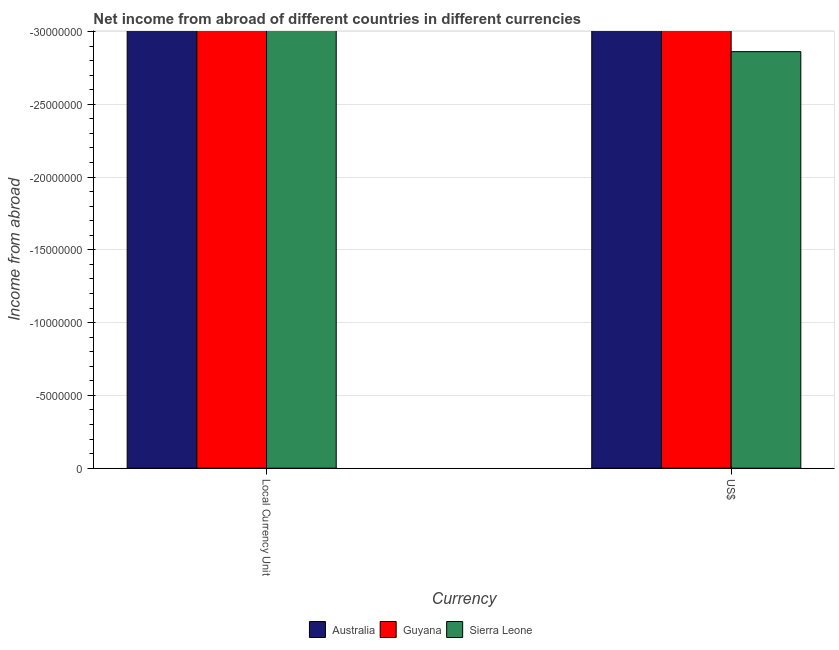How many different coloured bars are there?
Ensure brevity in your answer.  0. How many bars are there on the 2nd tick from the right?
Give a very brief answer. 0. What is the label of the 2nd group of bars from the left?
Ensure brevity in your answer.  US$. Across all countries, what is the minimum income from abroad in constant 2005 us$?
Your answer should be very brief. 0. What is the total income from abroad in constant 2005 us$ in the graph?
Provide a succinct answer. 0. What is the average income from abroad in constant 2005 us$ per country?
Offer a very short reply. 0. In how many countries, is the income from abroad in constant 2005 us$ greater than -7000000 units?
Make the answer very short. 0. Does the graph contain any zero values?
Provide a short and direct response. Yes. Where does the legend appear in the graph?
Your response must be concise. Bottom center. How many legend labels are there?
Offer a terse response. 3. How are the legend labels stacked?
Keep it short and to the point. Horizontal. What is the title of the graph?
Your response must be concise. Net income from abroad of different countries in different currencies. What is the label or title of the X-axis?
Provide a succinct answer. Currency. What is the label or title of the Y-axis?
Your response must be concise. Income from abroad. What is the Income from abroad of Australia in Local Currency Unit?
Make the answer very short. 0. What is the Income from abroad of Guyana in Local Currency Unit?
Provide a short and direct response. 0. What is the Income from abroad of Australia in US$?
Keep it short and to the point. 0. What is the Income from abroad in Guyana in US$?
Your answer should be very brief. 0. What is the Income from abroad in Sierra Leone in US$?
Provide a short and direct response. 0. What is the total Income from abroad of Australia in the graph?
Ensure brevity in your answer.  0. What is the total Income from abroad in Guyana in the graph?
Provide a succinct answer. 0. What is the average Income from abroad in Australia per Currency?
Make the answer very short. 0. What is the average Income from abroad of Sierra Leone per Currency?
Your answer should be compact. 0. 